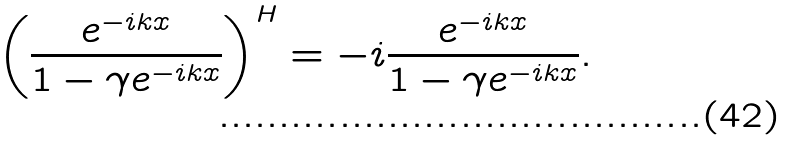<formula> <loc_0><loc_0><loc_500><loc_500>\left ( \frac { e ^ { - i k x } } { 1 - \gamma e ^ { - i k x } } \right ) ^ { H } = - i \frac { e ^ { - i k x } } { 1 - \gamma e ^ { - i k x } } .</formula> 